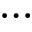<formula> <loc_0><loc_0><loc_500><loc_500>\dots</formula> 